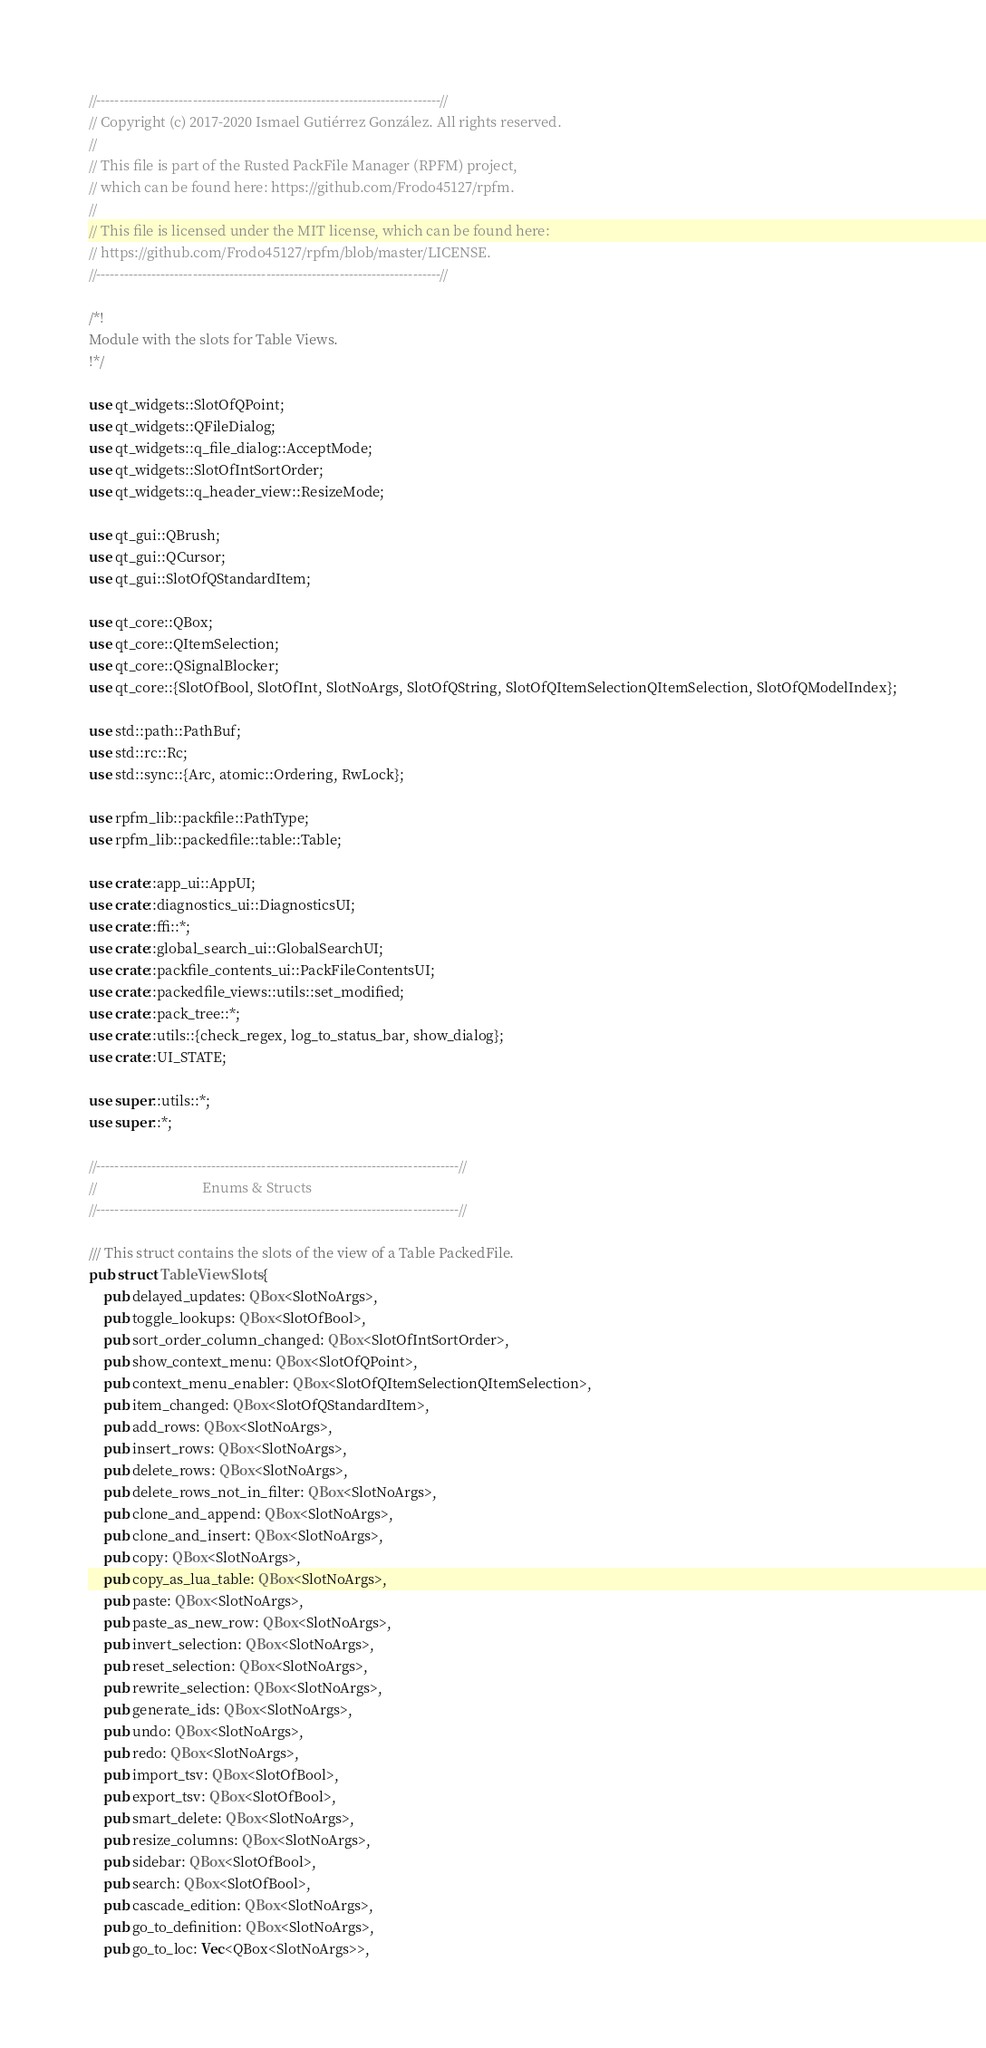<code> <loc_0><loc_0><loc_500><loc_500><_Rust_>//---------------------------------------------------------------------------//
// Copyright (c) 2017-2020 Ismael Gutiérrez González. All rights reserved.
//
// This file is part of the Rusted PackFile Manager (RPFM) project,
// which can be found here: https://github.com/Frodo45127/rpfm.
//
// This file is licensed under the MIT license, which can be found here:
// https://github.com/Frodo45127/rpfm/blob/master/LICENSE.
//---------------------------------------------------------------------------//

/*!
Module with the slots for Table Views.
!*/

use qt_widgets::SlotOfQPoint;
use qt_widgets::QFileDialog;
use qt_widgets::q_file_dialog::AcceptMode;
use qt_widgets::SlotOfIntSortOrder;
use qt_widgets::q_header_view::ResizeMode;

use qt_gui::QBrush;
use qt_gui::QCursor;
use qt_gui::SlotOfQStandardItem;

use qt_core::QBox;
use qt_core::QItemSelection;
use qt_core::QSignalBlocker;
use qt_core::{SlotOfBool, SlotOfInt, SlotNoArgs, SlotOfQString, SlotOfQItemSelectionQItemSelection, SlotOfQModelIndex};

use std::path::PathBuf;
use std::rc::Rc;
use std::sync::{Arc, atomic::Ordering, RwLock};

use rpfm_lib::packfile::PathType;
use rpfm_lib::packedfile::table::Table;

use crate::app_ui::AppUI;
use crate::diagnostics_ui::DiagnosticsUI;
use crate::ffi::*;
use crate::global_search_ui::GlobalSearchUI;
use crate::packfile_contents_ui::PackFileContentsUI;
use crate::packedfile_views::utils::set_modified;
use crate::pack_tree::*;
use crate::utils::{check_regex, log_to_status_bar, show_dialog};
use crate::UI_STATE;

use super::utils::*;
use super::*;

//-------------------------------------------------------------------------------//
//                              Enums & Structs
//-------------------------------------------------------------------------------//

/// This struct contains the slots of the view of a Table PackedFile.
pub struct TableViewSlots {
    pub delayed_updates: QBox<SlotNoArgs>,
    pub toggle_lookups: QBox<SlotOfBool>,
    pub sort_order_column_changed: QBox<SlotOfIntSortOrder>,
    pub show_context_menu: QBox<SlotOfQPoint>,
    pub context_menu_enabler: QBox<SlotOfQItemSelectionQItemSelection>,
    pub item_changed: QBox<SlotOfQStandardItem>,
    pub add_rows: QBox<SlotNoArgs>,
    pub insert_rows: QBox<SlotNoArgs>,
    pub delete_rows: QBox<SlotNoArgs>,
    pub delete_rows_not_in_filter: QBox<SlotNoArgs>,
    pub clone_and_append: QBox<SlotNoArgs>,
    pub clone_and_insert: QBox<SlotNoArgs>,
    pub copy: QBox<SlotNoArgs>,
    pub copy_as_lua_table: QBox<SlotNoArgs>,
    pub paste: QBox<SlotNoArgs>,
    pub paste_as_new_row: QBox<SlotNoArgs>,
    pub invert_selection: QBox<SlotNoArgs>,
    pub reset_selection: QBox<SlotNoArgs>,
    pub rewrite_selection: QBox<SlotNoArgs>,
    pub generate_ids: QBox<SlotNoArgs>,
    pub undo: QBox<SlotNoArgs>,
    pub redo: QBox<SlotNoArgs>,
    pub import_tsv: QBox<SlotOfBool>,
    pub export_tsv: QBox<SlotOfBool>,
    pub smart_delete: QBox<SlotNoArgs>,
    pub resize_columns: QBox<SlotNoArgs>,
    pub sidebar: QBox<SlotOfBool>,
    pub search: QBox<SlotOfBool>,
    pub cascade_edition: QBox<SlotNoArgs>,
    pub go_to_definition: QBox<SlotNoArgs>,
    pub go_to_loc: Vec<QBox<SlotNoArgs>>,</code> 